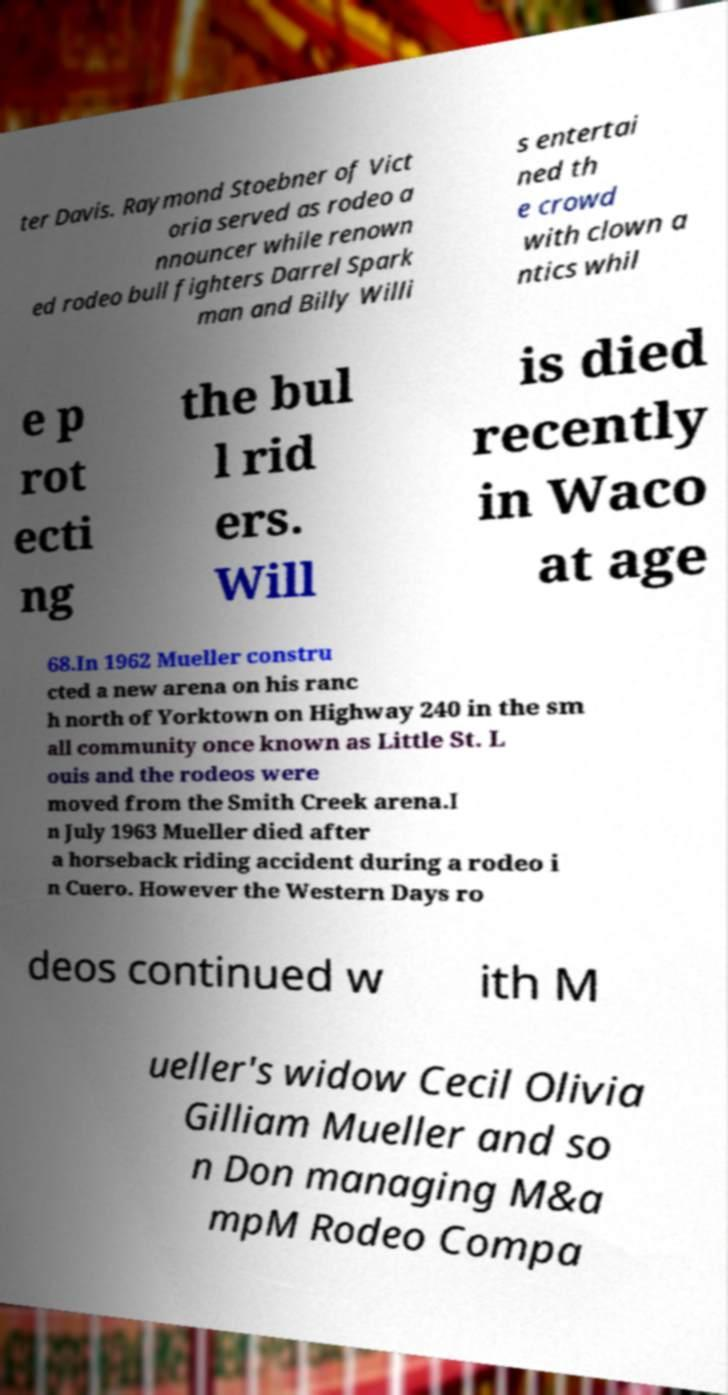Could you extract and type out the text from this image? ter Davis. Raymond Stoebner of Vict oria served as rodeo a nnouncer while renown ed rodeo bull fighters Darrel Spark man and Billy Willi s entertai ned th e crowd with clown a ntics whil e p rot ecti ng the bul l rid ers. Will is died recently in Waco at age 68.In 1962 Mueller constru cted a new arena on his ranc h north of Yorktown on Highway 240 in the sm all community once known as Little St. L ouis and the rodeos were moved from the Smith Creek arena.I n July 1963 Mueller died after a horseback riding accident during a rodeo i n Cuero. However the Western Days ro deos continued w ith M ueller's widow Cecil Olivia Gilliam Mueller and so n Don managing M&a mpM Rodeo Compa 